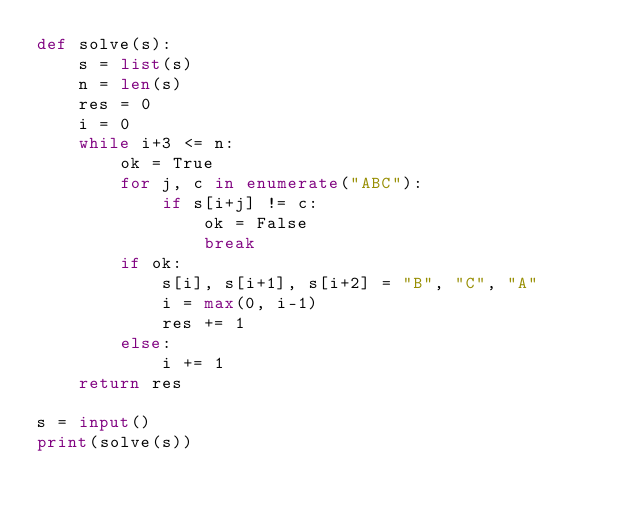<code> <loc_0><loc_0><loc_500><loc_500><_Python_>def solve(s):
    s = list(s)
    n = len(s)
    res = 0
    i = 0
    while i+3 <= n:
        ok = True
        for j, c in enumerate("ABC"):
            if s[i+j] != c:
                ok = False
                break
        if ok:
            s[i], s[i+1], s[i+2] = "B", "C", "A"
            i = max(0, i-1)
            res += 1
        else:
            i += 1
    return res

s = input()
print(solve(s))</code> 